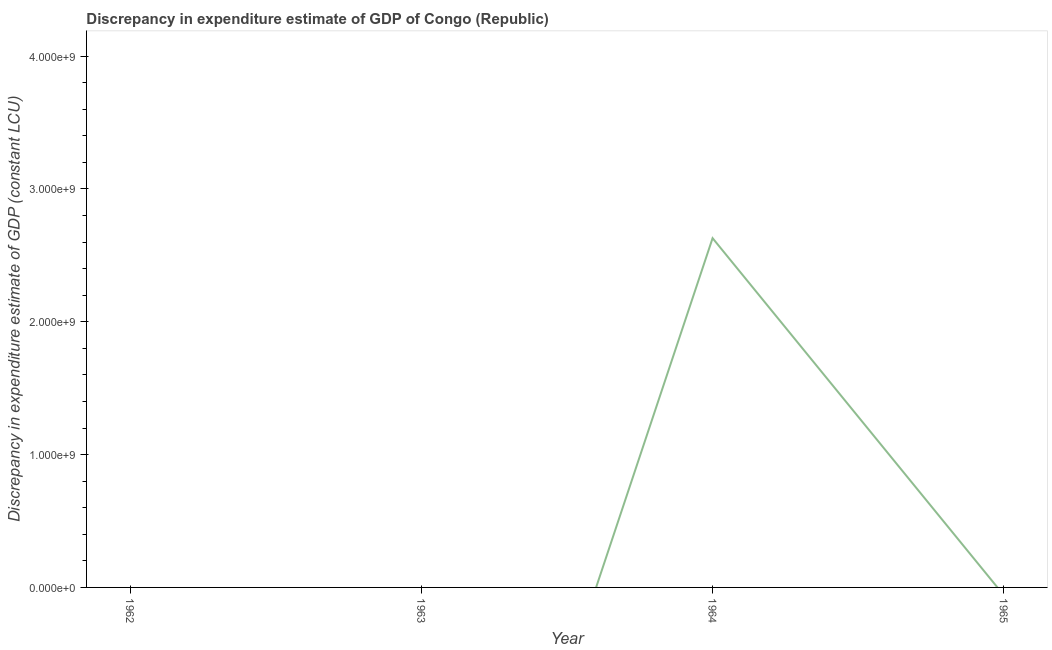What is the discrepancy in expenditure estimate of gdp in 1964?
Provide a succinct answer. 2.63e+09. Across all years, what is the maximum discrepancy in expenditure estimate of gdp?
Give a very brief answer. 2.63e+09. Across all years, what is the minimum discrepancy in expenditure estimate of gdp?
Your answer should be compact. 0. In which year was the discrepancy in expenditure estimate of gdp maximum?
Provide a succinct answer. 1964. What is the sum of the discrepancy in expenditure estimate of gdp?
Offer a terse response. 2.63e+09. What is the average discrepancy in expenditure estimate of gdp per year?
Your answer should be very brief. 6.57e+08. What is the median discrepancy in expenditure estimate of gdp?
Your answer should be compact. 0. What is the difference between the highest and the lowest discrepancy in expenditure estimate of gdp?
Make the answer very short. 2.63e+09. In how many years, is the discrepancy in expenditure estimate of gdp greater than the average discrepancy in expenditure estimate of gdp taken over all years?
Make the answer very short. 1. What is the difference between two consecutive major ticks on the Y-axis?
Provide a succinct answer. 1.00e+09. What is the title of the graph?
Keep it short and to the point. Discrepancy in expenditure estimate of GDP of Congo (Republic). What is the label or title of the X-axis?
Offer a terse response. Year. What is the label or title of the Y-axis?
Provide a succinct answer. Discrepancy in expenditure estimate of GDP (constant LCU). What is the Discrepancy in expenditure estimate of GDP (constant LCU) of 1962?
Offer a terse response. 0. What is the Discrepancy in expenditure estimate of GDP (constant LCU) in 1964?
Your response must be concise. 2.63e+09. 